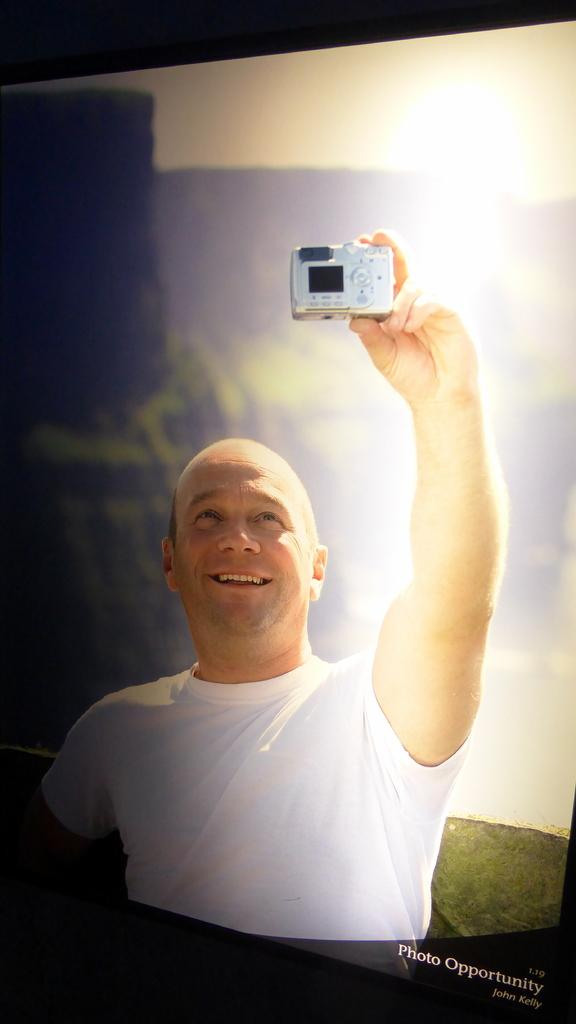Who is present in the image? There is a person in the image. What is the person wearing? The person is wearing a white shirt. What is the person holding in their left hand? The person is holding a camera in their left hand. What type of writing can be seen on the person's shirt in the image? There is no writing visible on the person's shirt in the image. What kind of wire is connected to the camera in the person's hand? There is no wire connected to the camera in the person's hand in the image. 